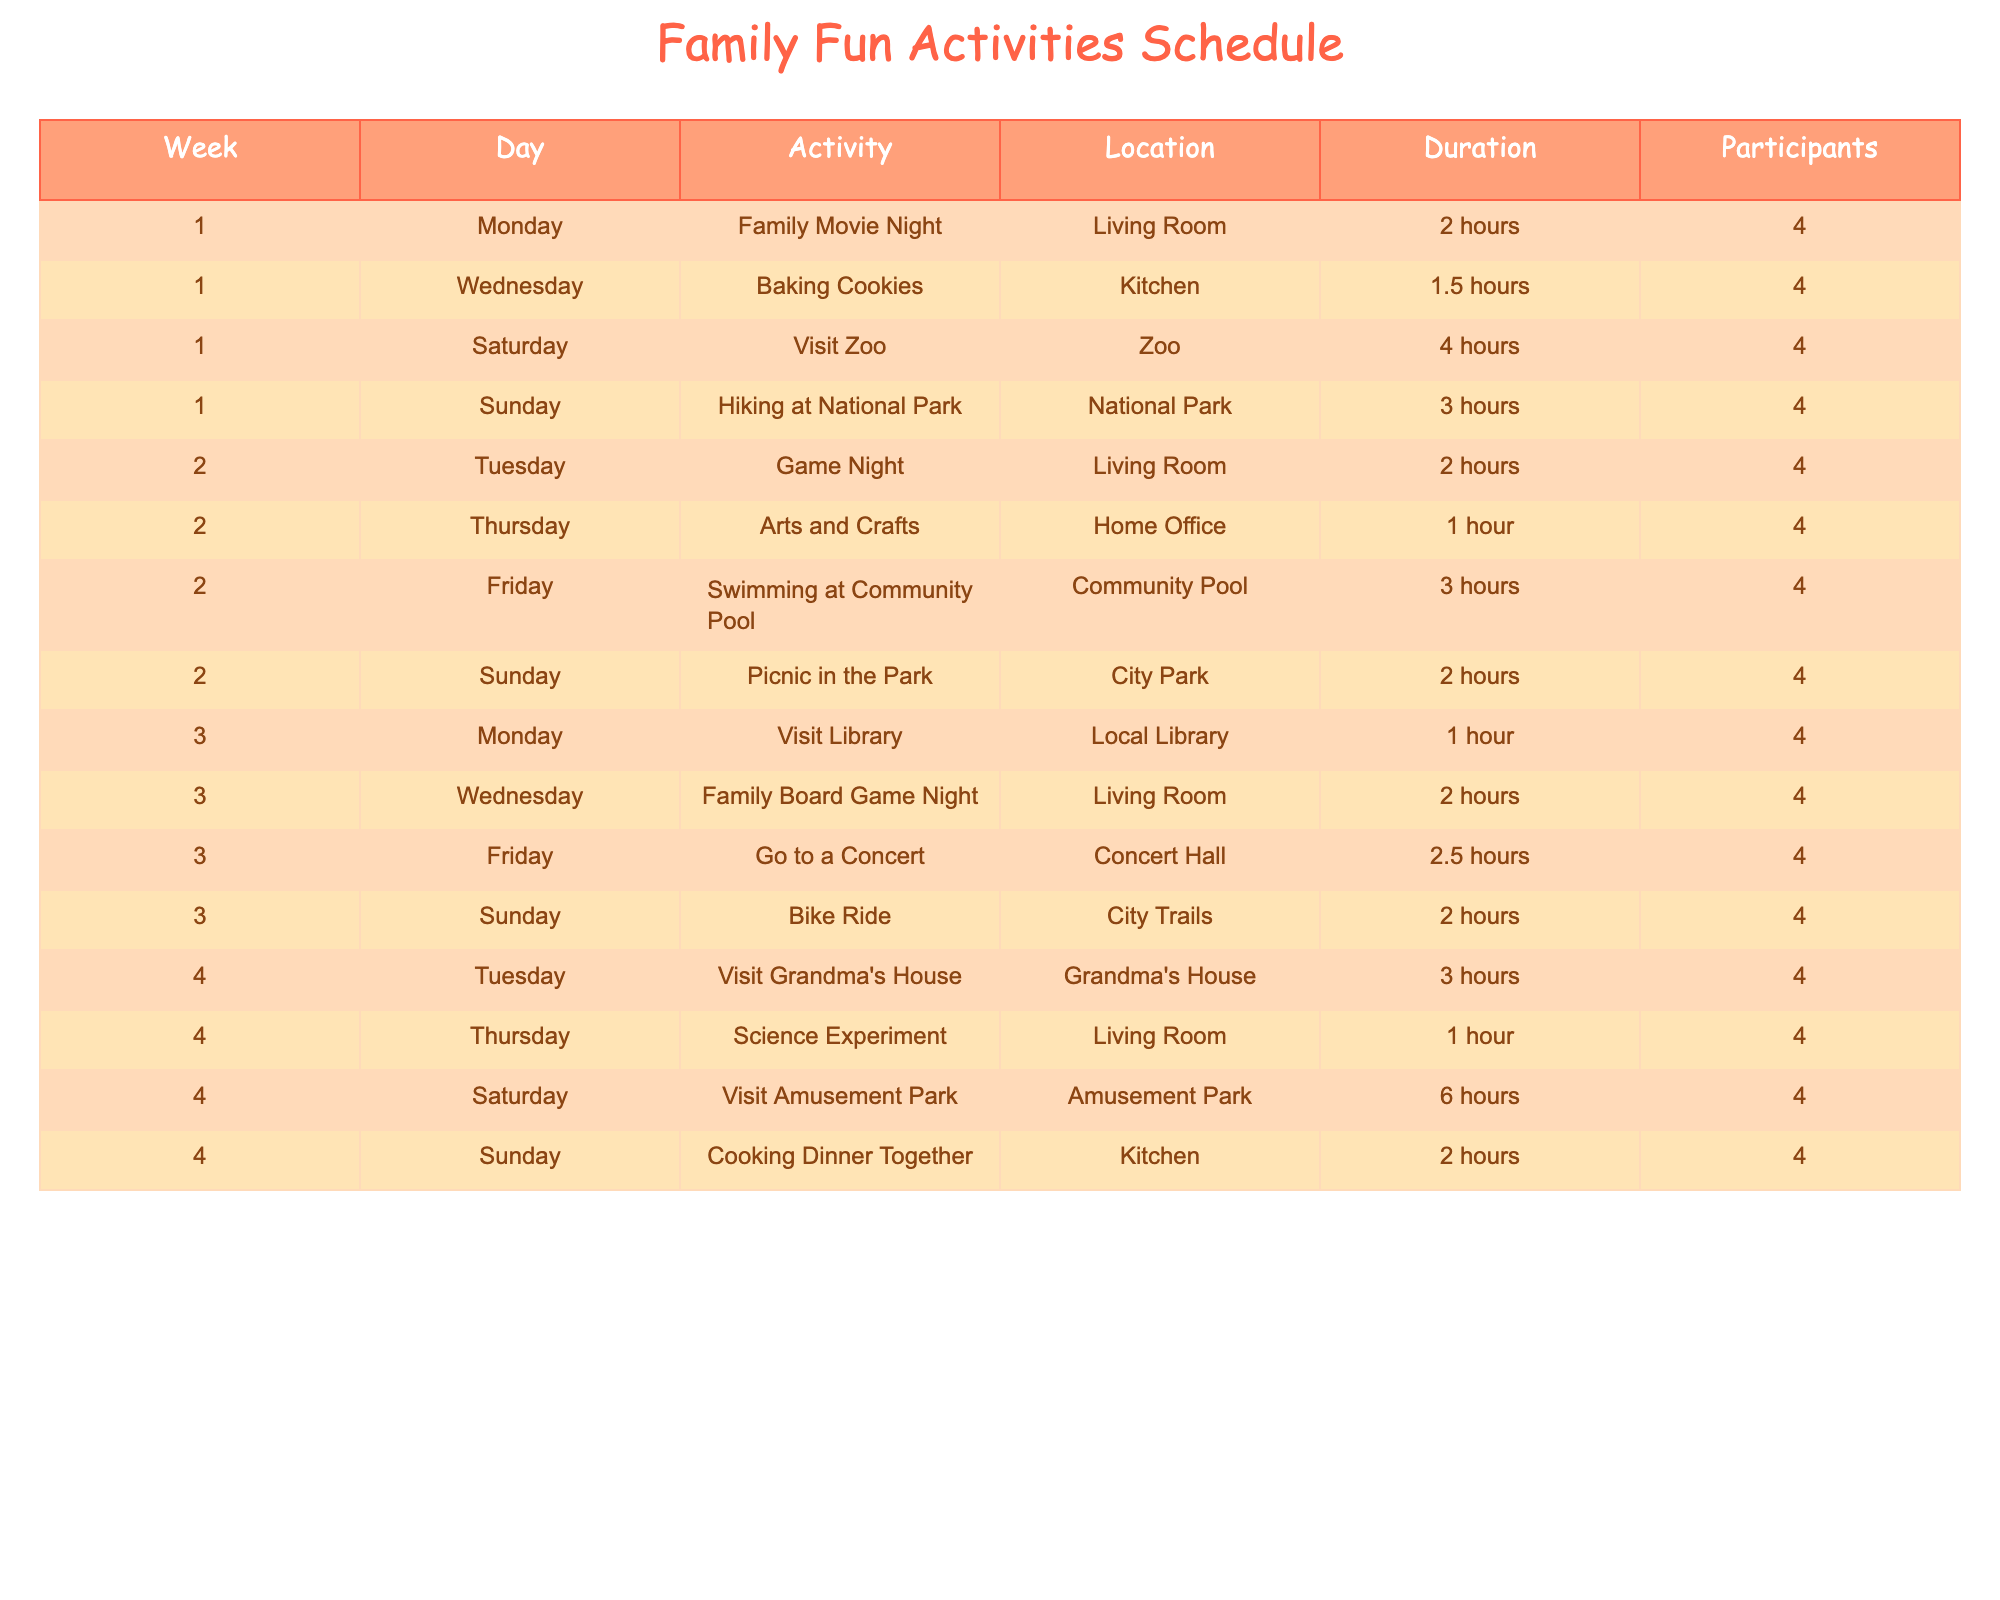What activity is planned for the first Saturday? The table shows that on the first Saturday, the planned activity is "Visit Zoo." This information is found by looking at the first week and locating the Saturday entry.
Answer: Visit Zoo What day is the Family Movie Night scheduled? According to the table, Family Movie Night is scheduled for Monday of the first week. You can find this by checking the activities listed under Week 1 and looking for "Family Movie Night."
Answer: Monday How many hours in total are planned for activities in Week 2? To determine the total hours planned for activities in Week 2, we add all the duration values from that week's activities: 2 + 1 + 3 + 2 = 8 hours. Thus, the total for Week 2 is 8 hours.
Answer: 8 hours Is there an activity scheduled on Friday of Week 4? The table indicates there is an activity on Friday of Week 4, which is "Visit Amusement Park." Therefore, the answer is yes since it directly matches an entry on that day.
Answer: Yes What is the average duration of all activities scheduled in Week 3? In Week 3, the durations are 1, 2, 2.5, and 2 hours. To find the average, we first add these durations: 1 + 2 + 2.5 + 2 = 7.5 hours. Then we divide by the number of activities (4): 7.5 / 4 = 1.875 hours. So the average duration is 1.875 hours.
Answer: 1.875 hours Which location hosts the most activities in the schedule? Analyzing the table, we see that "Living Room" has the most activities listed. It appears for Family Movie Night, Family Board Game Night, and Science Experiment, totaling 3 activities. Other locations have fewer.
Answer: Living Room What percentage of activities involves visiting places outside the home? In total, there are 16 activities scheduled. The activities that involve visiting outside locations include "Visit Zoo," "Visit Library," "Go to a Concert," "Visit Grandma's House," "Visit Amusement Park," and "Hiking at National Park," which totals to 6 activities. To find the percentage, we calculate (6/16) * 100 = 37.5%.
Answer: 37.5% How long is the Cooking Dinner Together activity planned for? The duration of the "Cooking Dinner Together" activity is 2 hours, which can be found directly by checking the Sunday entry in the fourth week.
Answer: 2 hours 